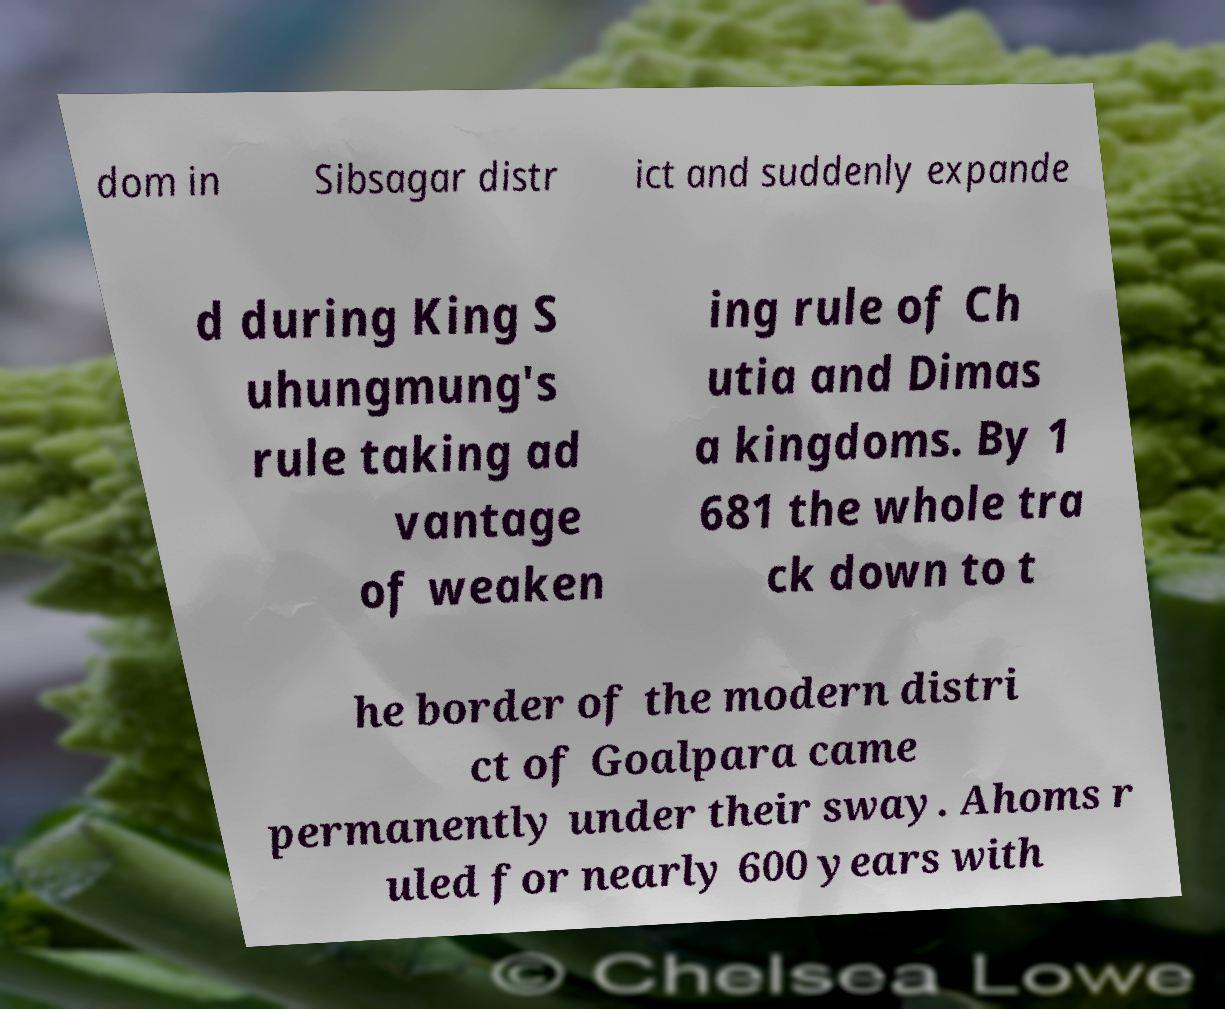Could you extract and type out the text from this image? dom in Sibsagar distr ict and suddenly expande d during King S uhungmung's rule taking ad vantage of weaken ing rule of Ch utia and Dimas a kingdoms. By 1 681 the whole tra ck down to t he border of the modern distri ct of Goalpara came permanently under their sway. Ahoms r uled for nearly 600 years with 